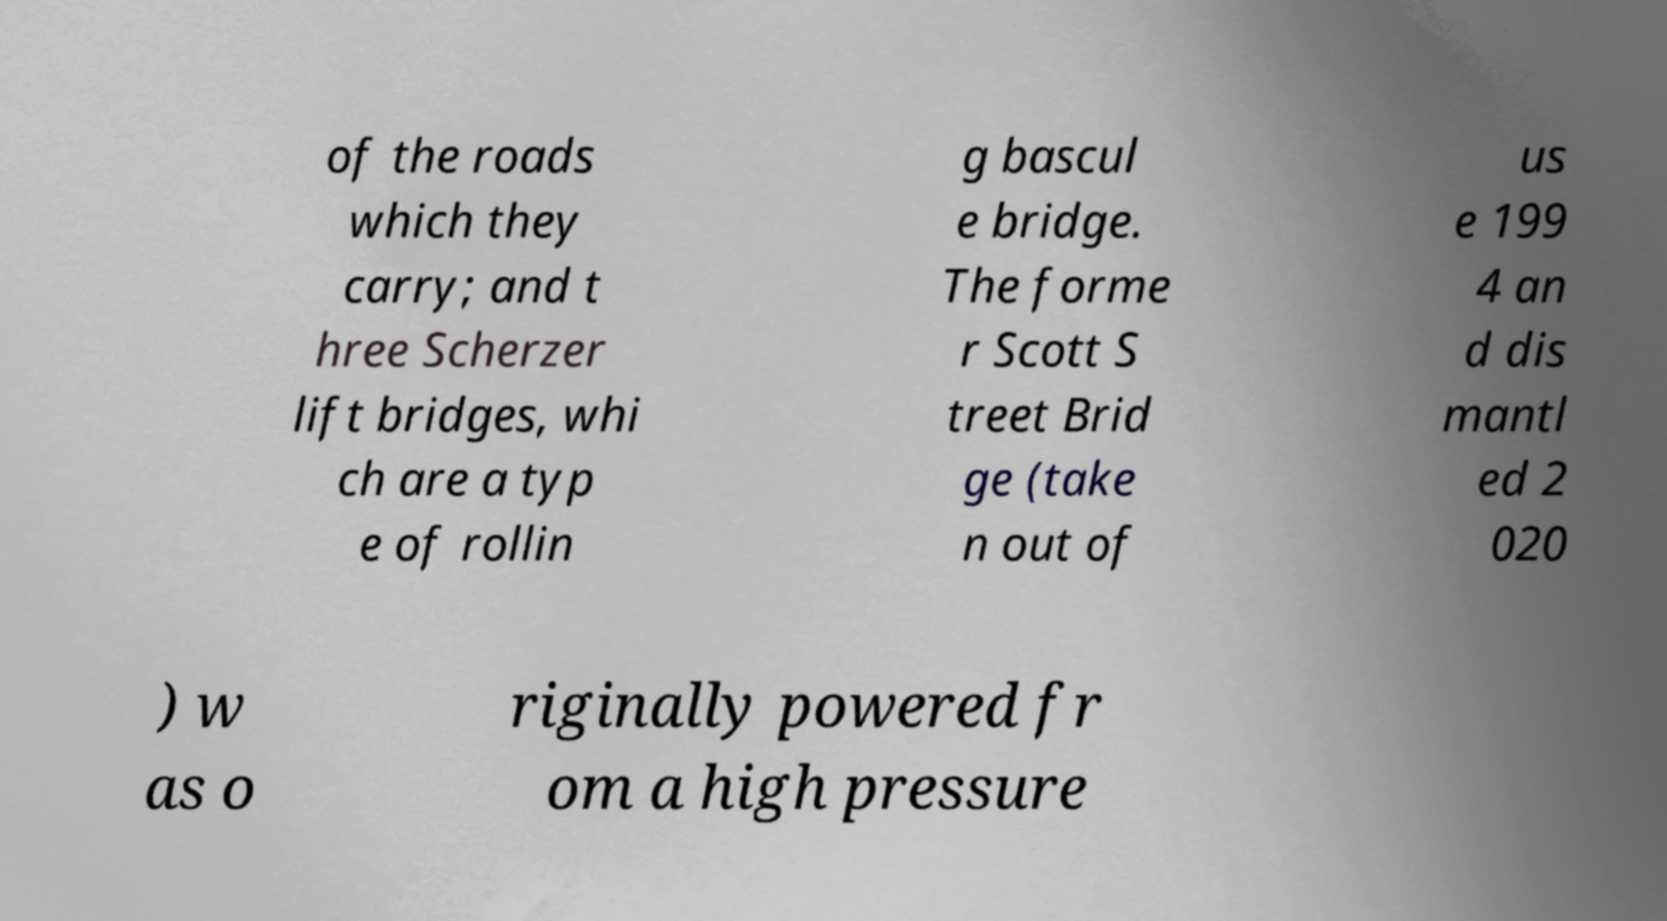Please read and relay the text visible in this image. What does it say? of the roads which they carry; and t hree Scherzer lift bridges, whi ch are a typ e of rollin g bascul e bridge. The forme r Scott S treet Brid ge (take n out of us e 199 4 an d dis mantl ed 2 020 ) w as o riginally powered fr om a high pressure 